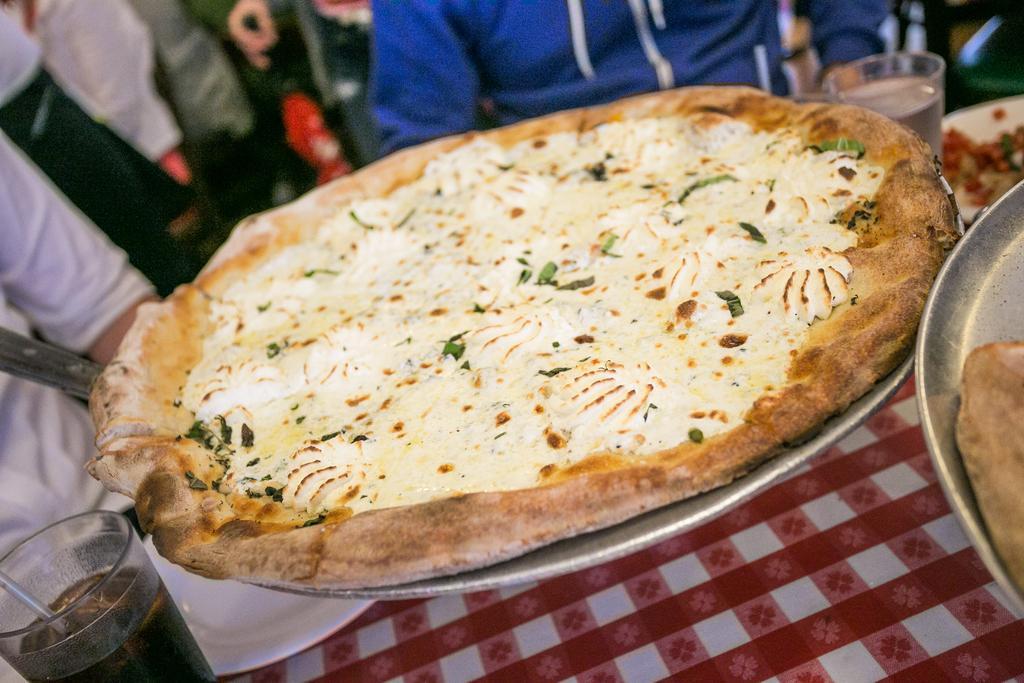Describe this image in one or two sentences. In this picture there is a pizza place in the plate. In the left side there is a glass in which there is some drink. The plate was placed on the table. We can observe two members sitting in front of the table. 